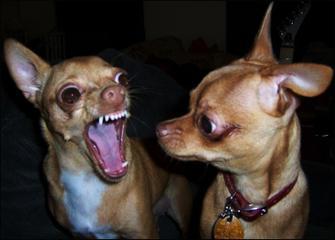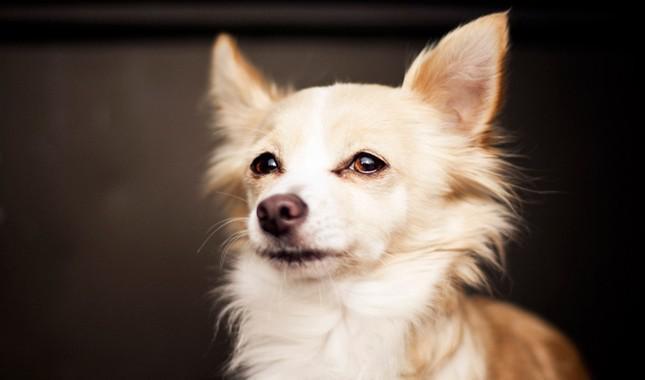The first image is the image on the left, the second image is the image on the right. Analyze the images presented: Is the assertion "One of the dogs in one of the images is baring its teeth." valid? Answer yes or no. Yes. 